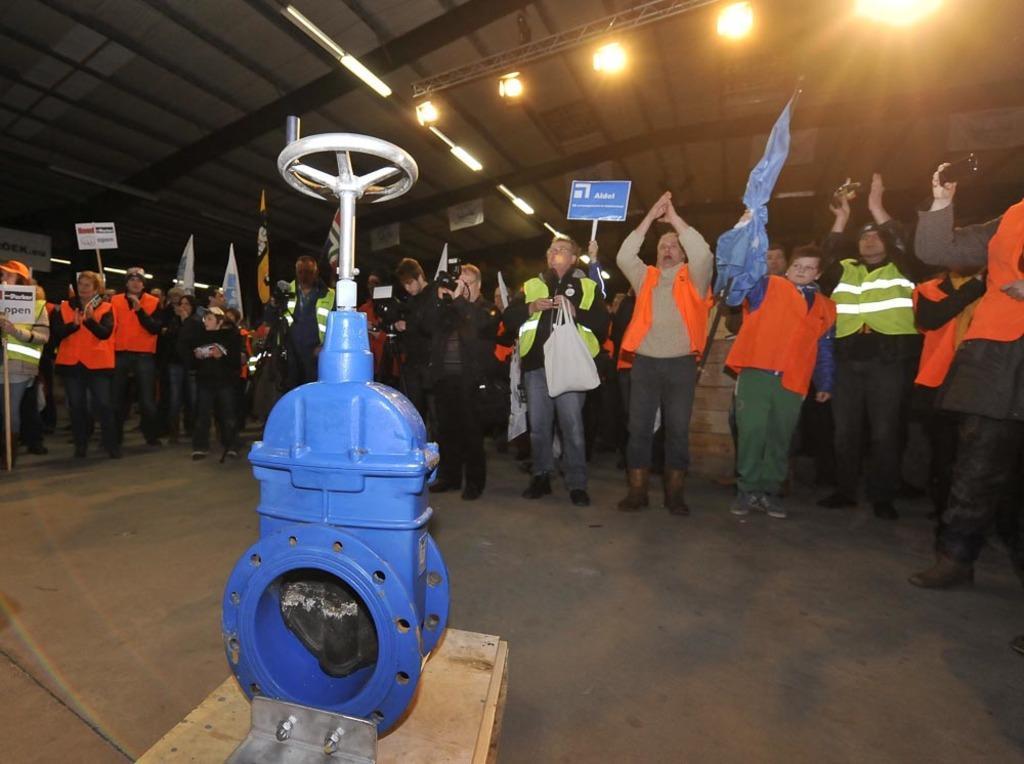How would you summarize this image in a sentence or two? In this picture we can see a machine and a group of people standing on the floor, flags, boards, lights, jackets. 